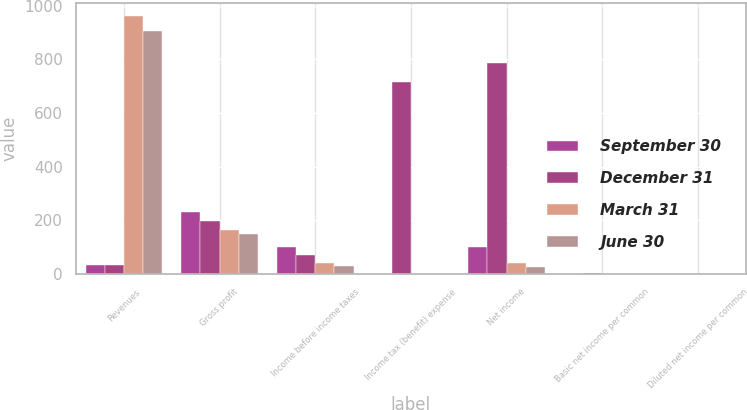Convert chart to OTSL. <chart><loc_0><loc_0><loc_500><loc_500><stacked_bar_chart><ecel><fcel>Revenues<fcel>Gross profit<fcel>Income before income taxes<fcel>Income tax (benefit) expense<fcel>Net income<fcel>Basic net income per common<fcel>Diluted net income per common<nl><fcel>September 30<fcel>34.9<fcel>232.5<fcel>99.2<fcel>0.9<fcel>100.1<fcel>0.31<fcel>0.3<nl><fcel>December 31<fcel>34.9<fcel>198.3<fcel>72.2<fcel>715.6<fcel>787.8<fcel>2.47<fcel>2.22<nl><fcel>March 31<fcel>961.2<fcel>164.4<fcel>42.3<fcel>1.7<fcel>40.6<fcel>0.13<fcel>0.13<nl><fcel>June 30<fcel>906.6<fcel>148.6<fcel>29.2<fcel>1.5<fcel>27.7<fcel>0.09<fcel>0.09<nl></chart> 